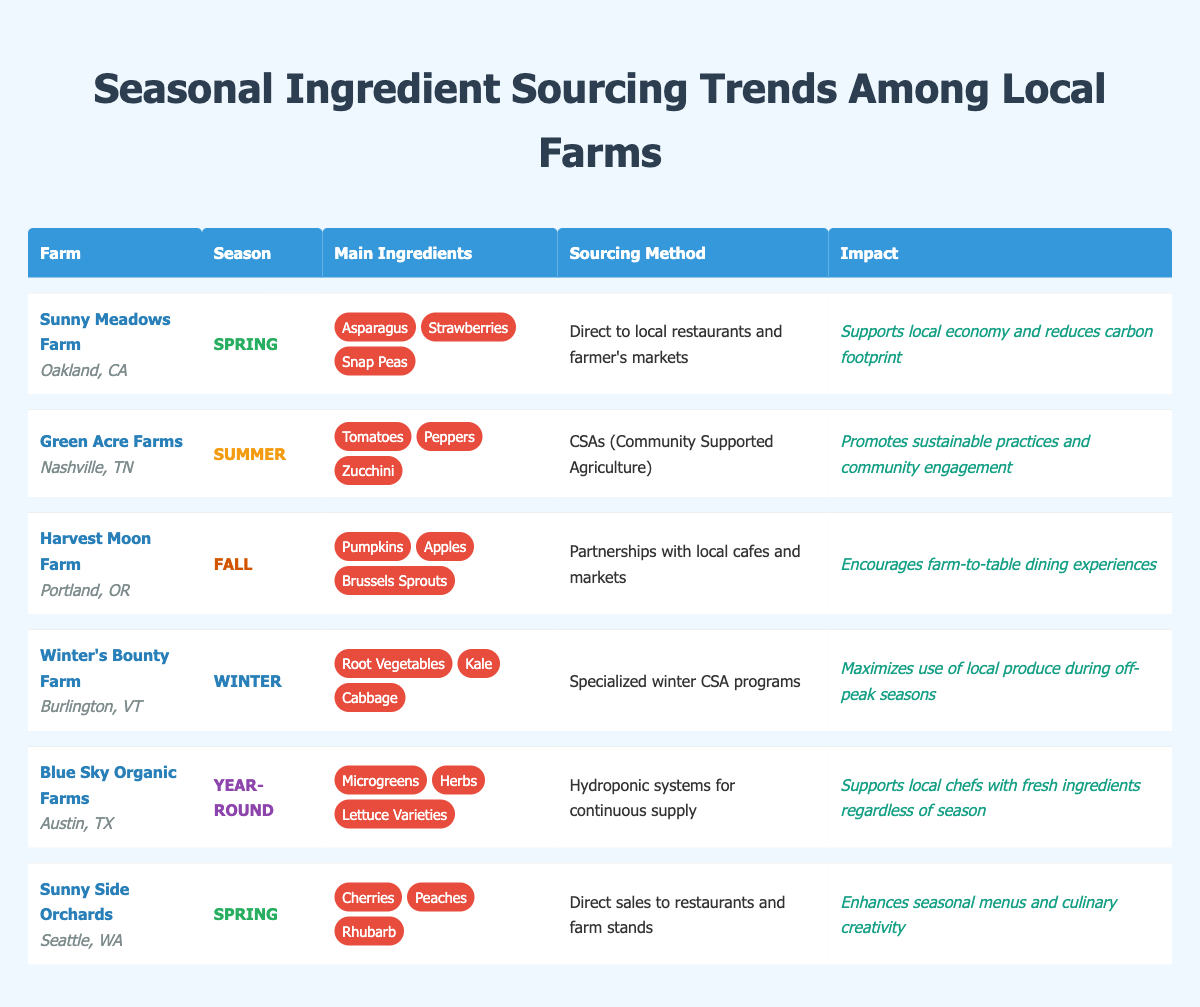What farm is located in Oakland, CA? The table lists all farms along with their locations. By scanning for "Oakland, CA," we find that "Sunny Meadows Farm" is the one located there.
Answer: Sunny Meadows Farm Which farm uses Community Supported Agriculture as its sourcing method? Looking at the sourcing method column, "Green Acre Farms" is the only farm listed with "CSAs (Community Supported Agriculture)" as its method.
Answer: Green Acre Farms What are the main ingredients for Winter's Bounty Farm? The table shows the main ingredients for each farm, and for Winter's Bounty Farm in Burlington, VT, the ingredients listed are "Root Vegetables," "Kale," and "Cabbage."
Answer: Root Vegetables, Kale, Cabbage How many farms source ingredients year-round? By counting the entries in the season column, "Blue Sky Organic Farms" is the only one that serves year-round.
Answer: 1 Which season has the most farms listed in the table? By examining the season column, we see there are two farms (Sunny Meadows Farm and Sunny Side Orchards) for Spring, one farm (Green Acre Farms) for Summer, one farm (Harvest Moon Farm) for Fall, and one farm (Winter's Bounty Farm) for Winter. Therefore, Spring has the most farms.
Answer: Spring Is the impact of Harvest Moon Farm focused on sustainability? By examining the impact column, Harvest Moon Farm's impact is "Encourages farm-to-table dining experiences," which does not explicitly mention sustainability, so the answer is no.
Answer: No What sourcing method is used by the farm located in Portland, OR? The table indicates that "Harvest Moon Farm" in Portland, OR, uses "Partnerships with local cafes and markets" as its sourcing method.
Answer: Partnerships with local cafes and markets Which farm has the greatest variety of main ingredients? Blue Sky Organic Farms offers "Microgreens," "Herbs," and "Lettuce Varieties," totaling three ingredients. The other farms listed also provide three ingredients, but no single farm exceeds this count. Thus, they are all tied for variety.
Answer: All have the same variety (3 ingredients each) What is the main impact of Winter's Bounty Farm? The table specifies that Winter's Bounty Farm's impact is to "Maximize use of local produce during off-peak seasons."
Answer: Maximize use of local produce during off-peak seasons Which farm supports local chefs with fresh ingredients throughout all seasons? The table directly states that Blue Sky Organic Farms supports local chefs with a continuous supply of ingredients, specifically mentioning year-round operation.
Answer: Blue Sky Organic Farms How does sourcing method differ between Sunny Meadows Farm and Green Acre Farms? Sunny Meadows Farm uses "Direct to local restaurants and farmer's markets," while Green Acre Farms employs "CSAs (Community Supported Agriculture)." Thus, their methods differ in community engagement versus direct sales.
Answer: They differ: Direct sales vs CSAs What types of ingredients does Sunny Side Orchards primarily provide? The table indicates that Sunny Side Orchards provides "Cherries," "Peaches," and "Rhubarb" as its main ingredients in Spring.
Answer: Cherries, Peaches, Rhubarb 